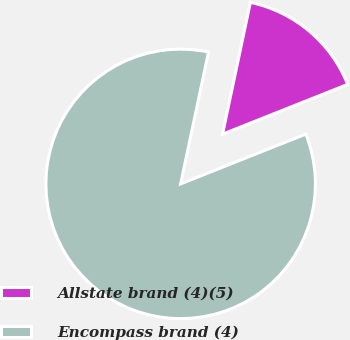Convert chart. <chart><loc_0><loc_0><loc_500><loc_500><pie_chart><fcel>Allstate brand (4)(5)<fcel>Encompass brand (4)<nl><fcel>15.66%<fcel>84.34%<nl></chart> 